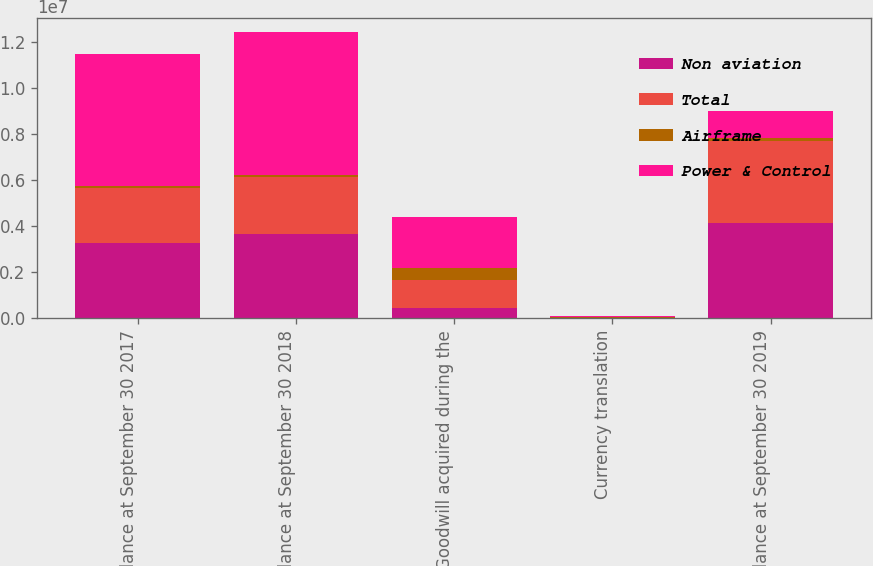Convert chart to OTSL. <chart><loc_0><loc_0><loc_500><loc_500><stacked_bar_chart><ecel><fcel>Balance at September 30 2017<fcel>Balance at September 30 2018<fcel>Goodwill acquired during the<fcel>Currency translation<fcel>Balance at September 30 2019<nl><fcel>Non aviation<fcel>3.26998e+06<fcel>3.67768e+06<fcel>468613<fcel>16422<fcel>4.12118e+06<nl><fcel>Total<fcel>2.38208e+06<fcel>2.45233e+06<fcel>1.18e+06<fcel>11695<fcel>3.59774e+06<nl><fcel>Airframe<fcel>93275<fcel>93275<fcel>545712<fcel>14813<fcel>101184<nl><fcel>Power & Control<fcel>5.74534e+06<fcel>6.22329e+06<fcel>2.19432e+06<fcel>42930<fcel>1.18e+06<nl></chart> 